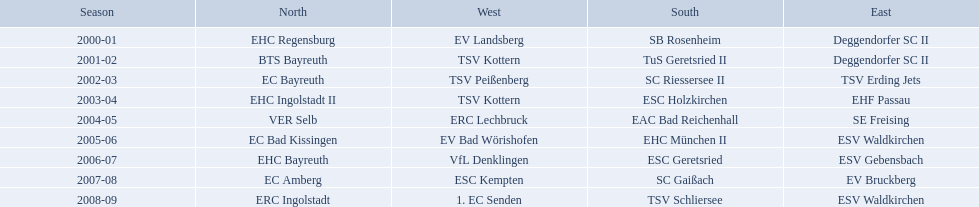Which teams played in the north? EHC Regensburg, BTS Bayreuth, EC Bayreuth, EHC Ingolstadt II, VER Selb, EC Bad Kissingen, EHC Bayreuth, EC Amberg, ERC Ingolstadt. Of these teams, which played during 2000-2001? EHC Regensburg. 